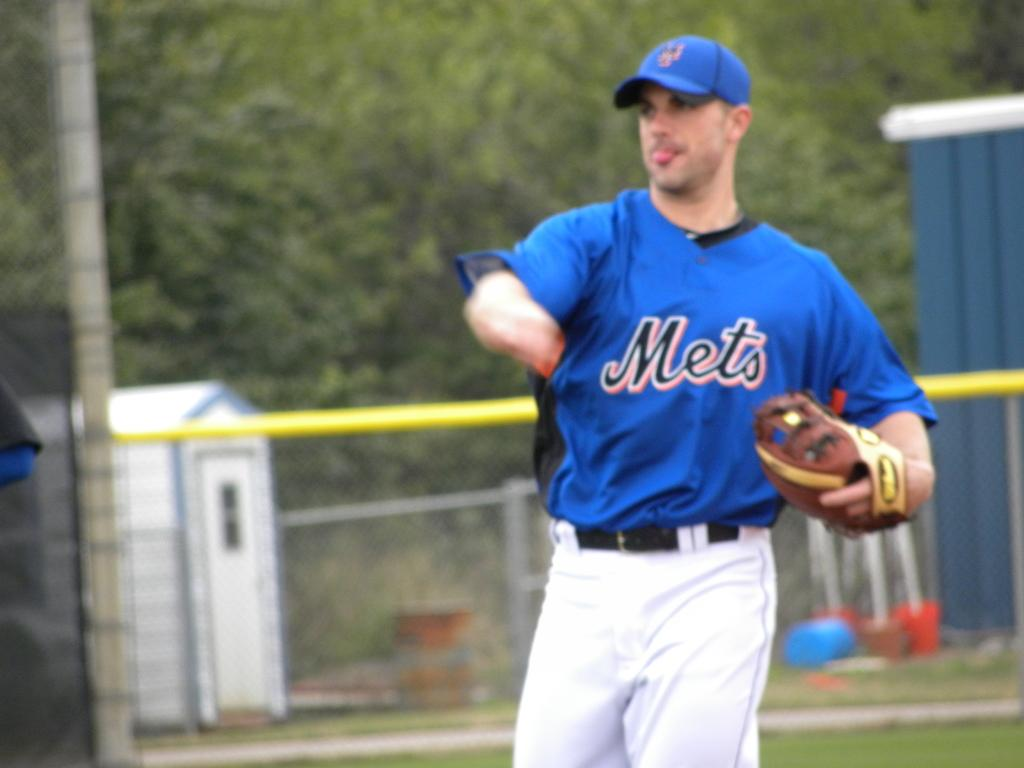<image>
Create a compact narrative representing the image presented. A baseball player for the Mets has thrown a ball. 